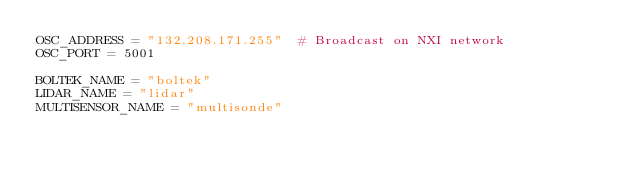<code> <loc_0><loc_0><loc_500><loc_500><_Python_>OSC_ADDRESS = "132.208.171.255"  # Broadcast on NXI network
OSC_PORT = 5001

BOLTEK_NAME = "boltek"
LIDAR_NAME = "lidar"
MULTISENSOR_NAME = "multisonde"
</code> 